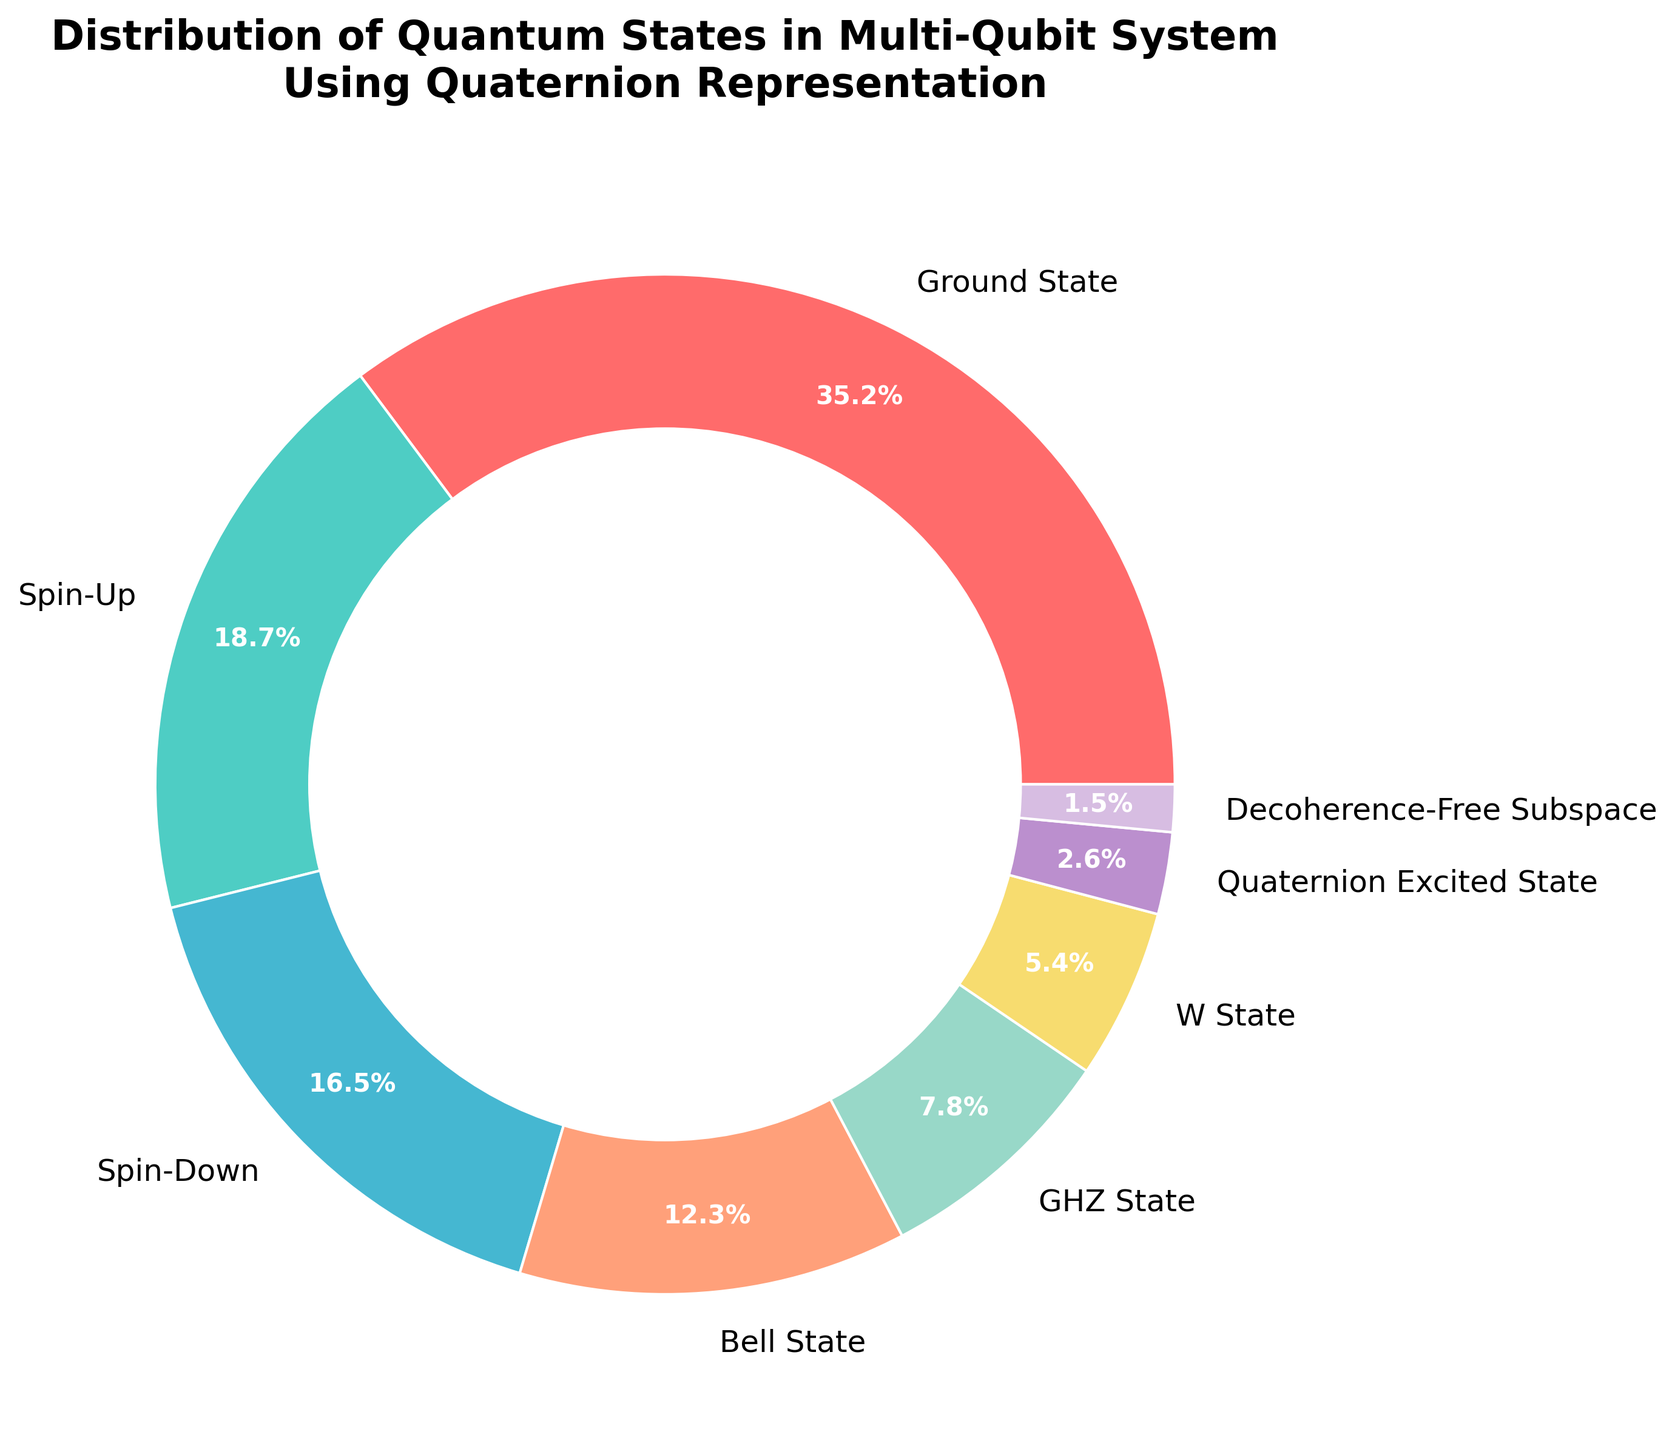What's the total percentage for Spin-Up and Spin-Down states combined? To find the total percentage of Spin-Up and Spin-Down states, add their individual percentages together: 18.7% + 16.5% = 35.2%
Answer: 35.2% Which state has the smallest percentage? The state with the smallest percentage is the one with the lowest numerical value listed. From the data, this is the Decoherence-Free Subspace with 1.5%
Answer: Decoherence-Free Subspace How does the percentage of the Bell State compare to the W State? To compare the Bell State and the W State percentages, note that the Bell State is 12.3%, and the W State is 5.4%. 12.3% is greater than 5.4%
Answer: Bell State is greater Which state has the highest percentage and what is its value? The state with the highest percentage can be identified by locating the largest value in the data. Here, the Ground State has the highest value at 35.2%
Answer: Ground State, 35.2% What is the difference in percentage between the GHZ State and the Quaternion Excited State? To find the percentage difference between the GHZ State and the Quaternion Excited State, subtract the smaller percentage from the larger one: 7.8% - 2.6% = 5.2%
Answer: 5.2% Which states have a combined percentage of greater than 50%? Add up the percentages of the states until the cumulation exceeds 50%: Ground State (35.2%) and Spin-Up (18.7%) give a total of 53.9%
Answer: Ground State, Spin-Up Arrange the states from highest to lowest percentage. Order the states based on their respective percentages from highest to lowest: Ground State (35.2%), Spin-Up (18.7%), Spin-Down (16.5%), Bell State (12.3%), GHZ State (7.8%), W State (5.4%), Quaternion Excited State (2.6%), Decoherence-Free Subspace (1.5%)
Answer: Ground State, Spin-Up, Spin-Down, Bell State, GHZ State, W State, Quaternion Excited State, Decoherence-Free Subspace What combined percentage does the W State and the Decoherence-Free Subspace account for? Add the percentages of the W State and the Decoherence-Free Subspace to find their combined total: 5.4% + 1.5% = 6.9%
Answer: 6.9% What is the total percentage of states other than the Ground State? Subtract the Ground State percentage from 100% to find the total percentage of all other states: 100% - 35.2% = 64.8%
Answer: 64.8% Identify the states occupying less than 10% each of the total distribution. Identify which states have percentages less than 10% by reviewing the given data: GHZ State (7.8%), W State (5.4%), Quaternion Excited State (2.6%), Decoherence-Free Subspace (1.5%)
Answer: GHZ State, W State, Quaternion Excited State, Decoherence-Free Subspace 